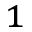Convert formula to latex. <formula><loc_0><loc_0><loc_500><loc_500>^ { 1 }</formula> 